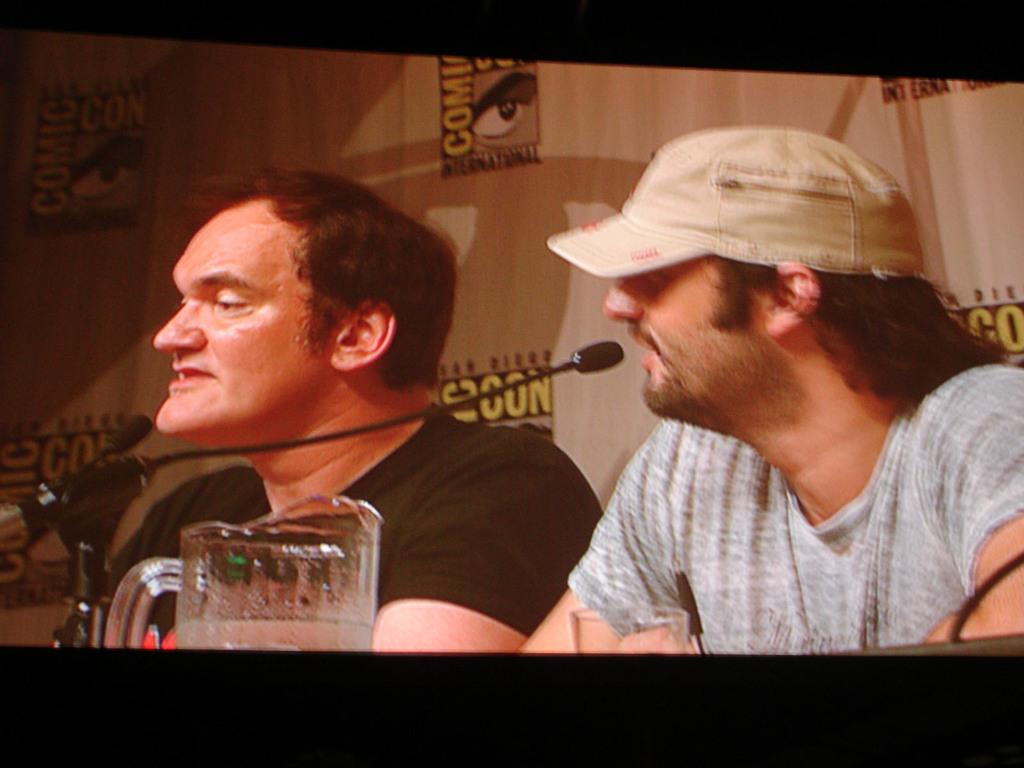What is the main object in the image? There is a huge screen in the image. What can be seen on the screen? Two persons are visible on the screen. What objects are in front of the persons on the screen? There is a glass and a microphone in front of the persons on the screen. What is the color of the background in the image? The background of the image is brown in color. Can you tell me how many gates are present on the island in the image? There is no island or gates present in the image; it features a huge screen with two persons and objects in front of them. What type of mouth is visible on the persons in the image? There are no visible mouths on the persons in the image, as they are only visible on the screen. 